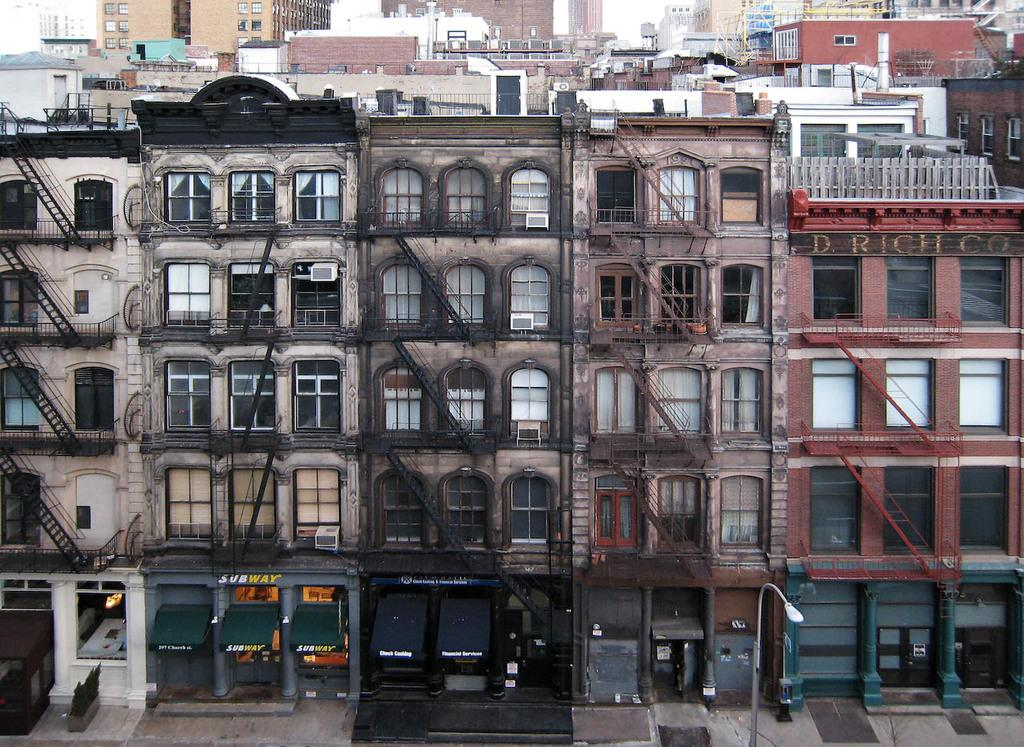What type of structures can be seen in the image? There are buildings in the image. What architectural feature is present in the image? There are railings in the image. What can be seen through the windows in the image? There are windows in the image, but the conversation does not provide information about what can be seen through them. What type of establishments are present in the image? There are stores in the image. What type of vertical structure is present in the image? There is a light pole in the image. What type of natural elements are present in the image? There are plants in the image. What type of objects are present in the image? There are objects in the image, but the conversation does not provide specific details about them. How many girls are visible in the image? There is no mention of girls in the provided facts, so it cannot be determined from the image. What type of work is the laborer performing in the image? There is no mention of a laborer or any work being performed in the provided facts, so it cannot be determined from the image. 